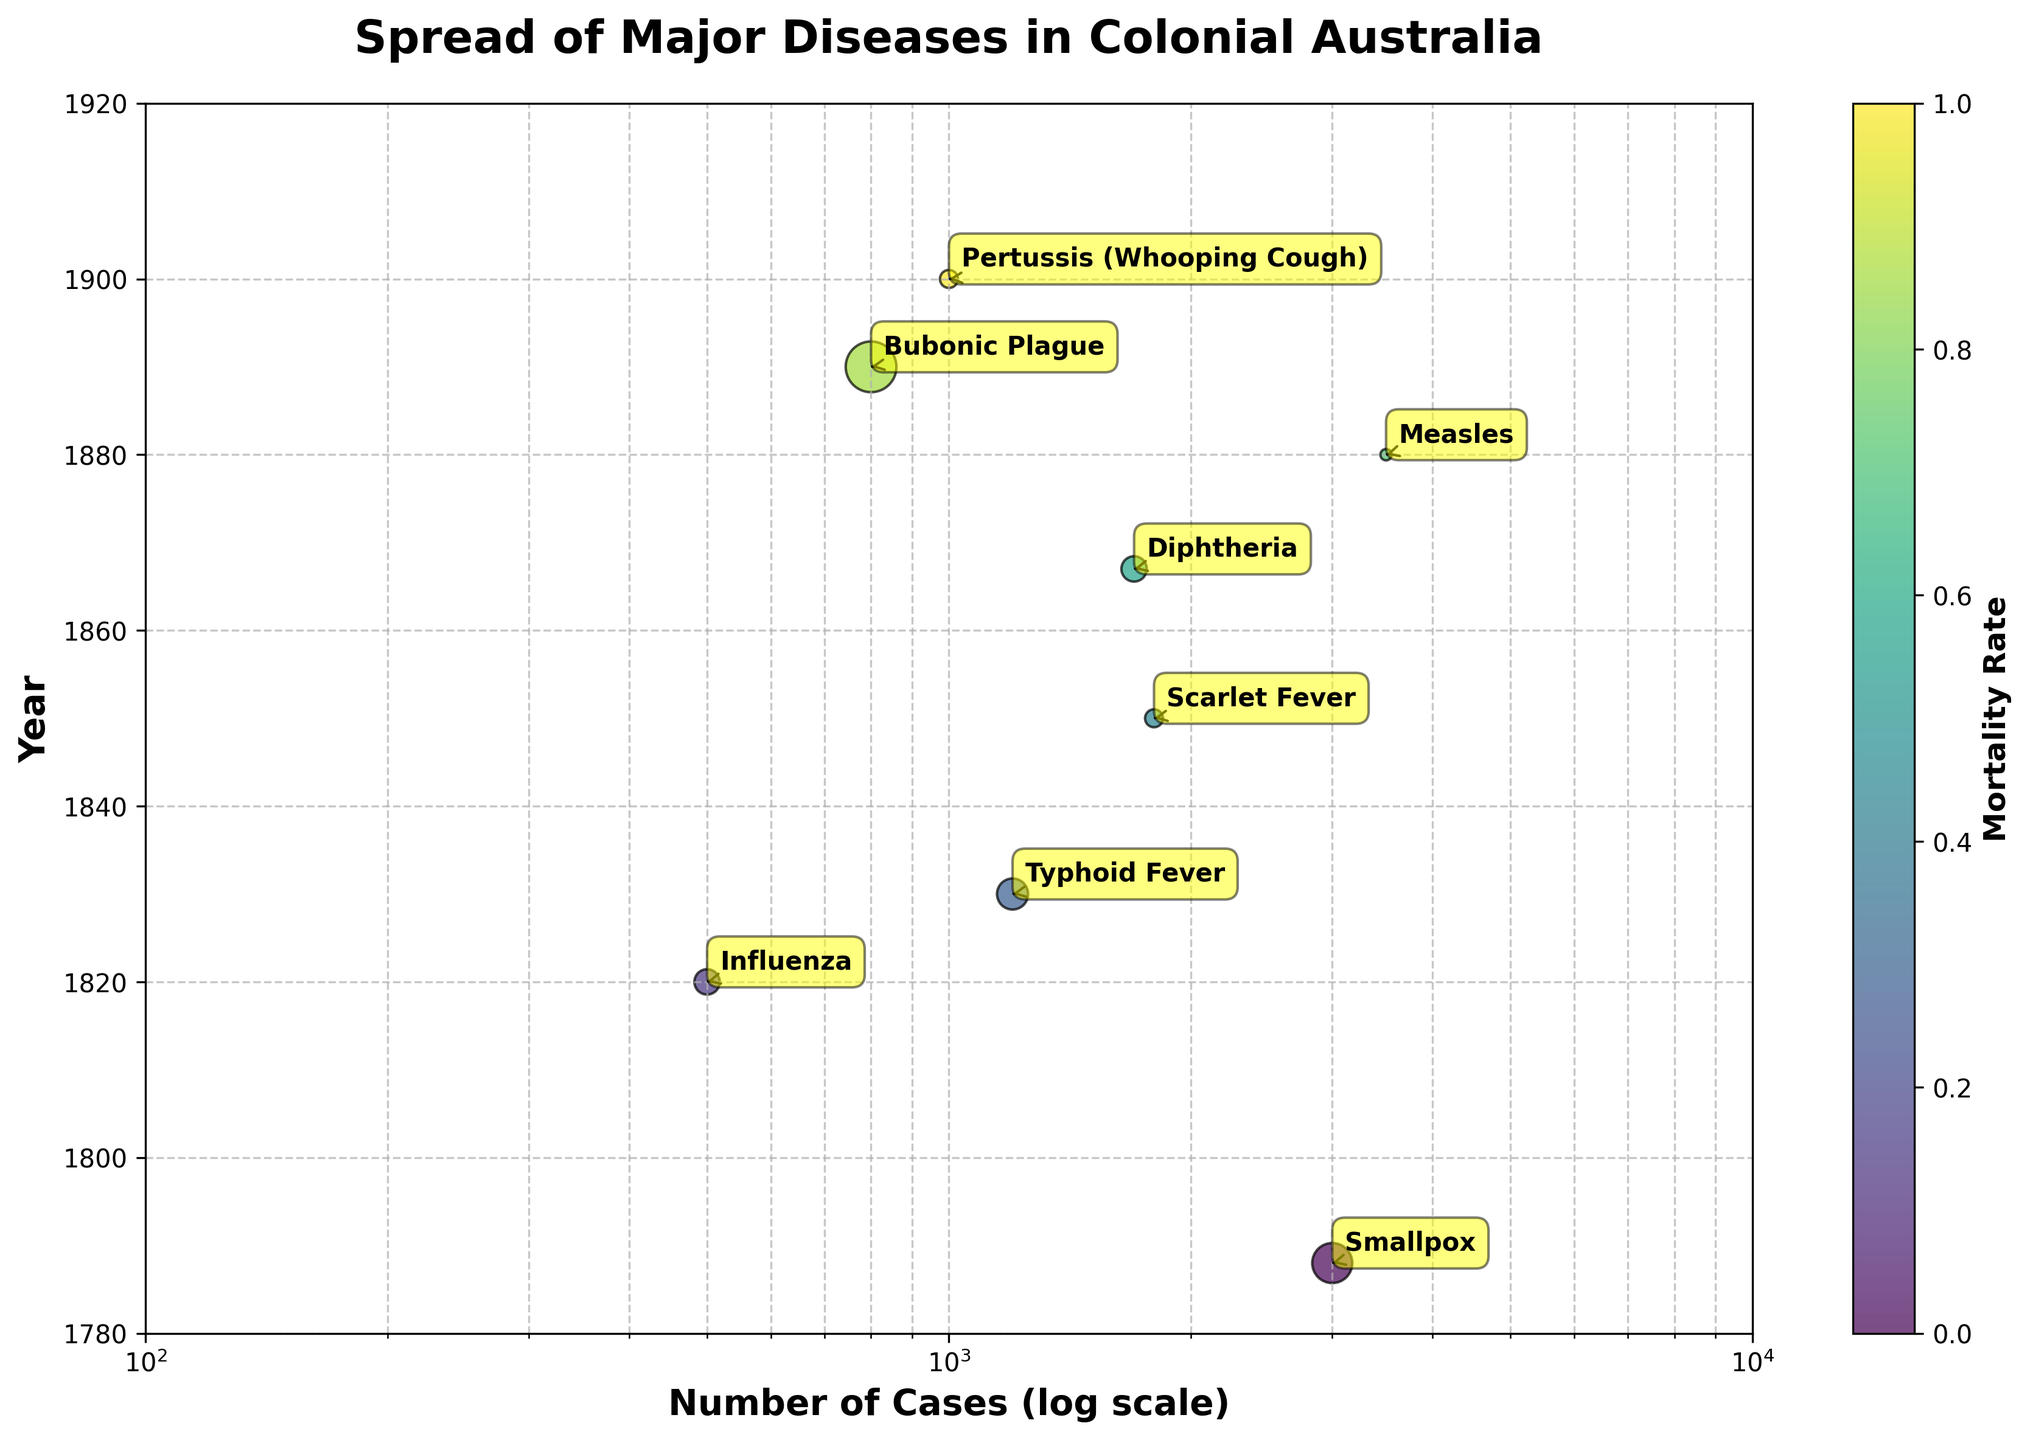What's the title of the figure? The title is usually found at the top of the figure, and in this case, it reads, "Spread of Major Diseases in Colonial Australia."
Answer: Spread of Major Diseases in Colonial Australia What are the axes labels? The x-axis label is noted below the horizontal line and the y-axis label beside the vertical line. In this figure, the x-axis label is "Number of Cases (log scale)" and the y-axis label is "Year."
Answer: Number of Cases (log scale) and Year How many diseases are represented in the figure? By counting the number of labeled points or data annotations on the scatter plot, we can determine the number of diseases represented. There are 8 data points, each representing a different disease.
Answer: 8 Which disease had the highest number of cases? The highest number of cases is indicated by the rightmost point on the logarithmic x-axis. The annotation near this point is "Measles," which corresponds to the highest number of cases.
Answer: Measles Which disease had the lowest mortality rate? The sizes of the scatter plot points correspond to the mortality rates. The smallest point, which is for Scarlet Fever, indicates the lowest mortality rate among the diseases.
Answer: Scarlet Fever Did any disease have a mortality rate higher than 0.3? By observing the size and color of the points, we note that Bubonic Plague has a relatively large point and darker color, indicating a high mortality rate over 0.3.
Answer: Yes, Bubonic Plague Which decade had the most variety of diseases reported? By counting the number of distinct disease labels within each decade along the y-axis, we can see that the 1890s reported the most varied diseases, including Measles, Bubonic Plague, and Pertussis (Whooping Cough).
Answer: 1890s Compare the mortality rate of Smallpox and Diphtheria. Which one is higher? By observing the size of the points for both Smallpox and Diphtheria, the larger size of the Smallpox point indicates a higher mortality rate than that of the Diphtheria point.
Answer: Smallpox In which year was Smallpox reported, and what was its mortality rate? The annotation for Smallpox on the scatter plot shows the year along the y-axis, and by noting the size of its point, the mortality rate can be inferred from the legend. Smallpox was reported in 1788 with a 0.25 mortality rate.
Answer: 1788, 0.25 